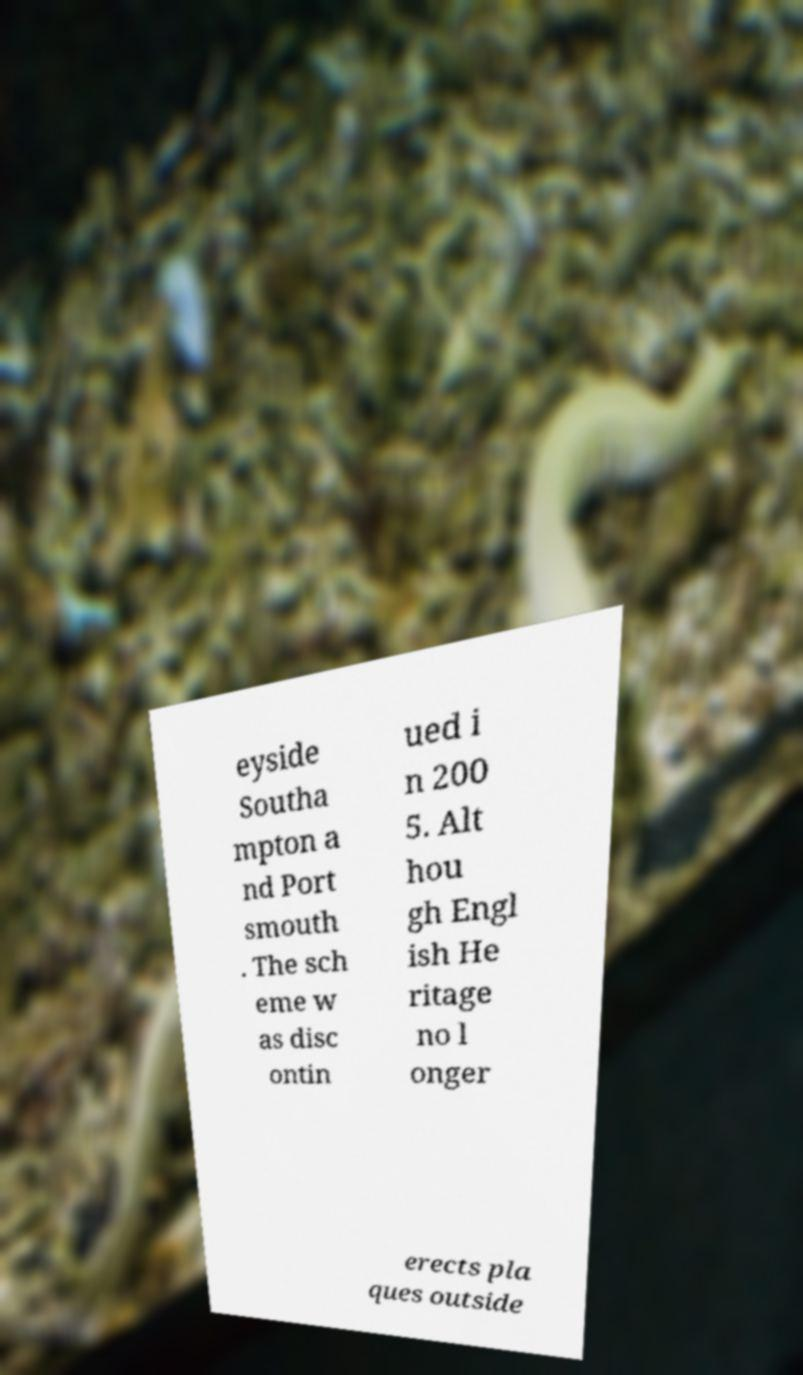Could you extract and type out the text from this image? eyside Southa mpton a nd Port smouth . The sch eme w as disc ontin ued i n 200 5. Alt hou gh Engl ish He ritage no l onger erects pla ques outside 